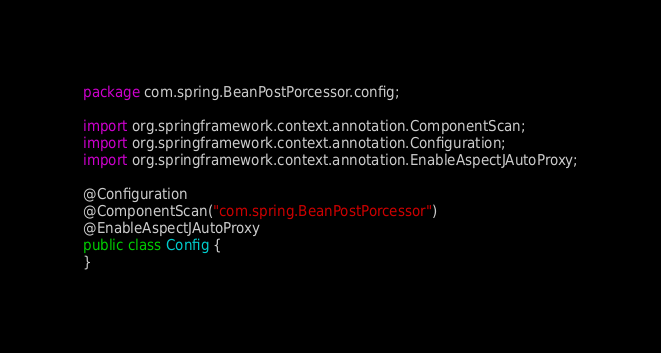<code> <loc_0><loc_0><loc_500><loc_500><_Java_>package com.spring.BeanPostPorcessor.config;

import org.springframework.context.annotation.ComponentScan;
import org.springframework.context.annotation.Configuration;
import org.springframework.context.annotation.EnableAspectJAutoProxy;

@Configuration
@ComponentScan("com.spring.BeanPostPorcessor")
@EnableAspectJAutoProxy
public class Config {
}
</code> 